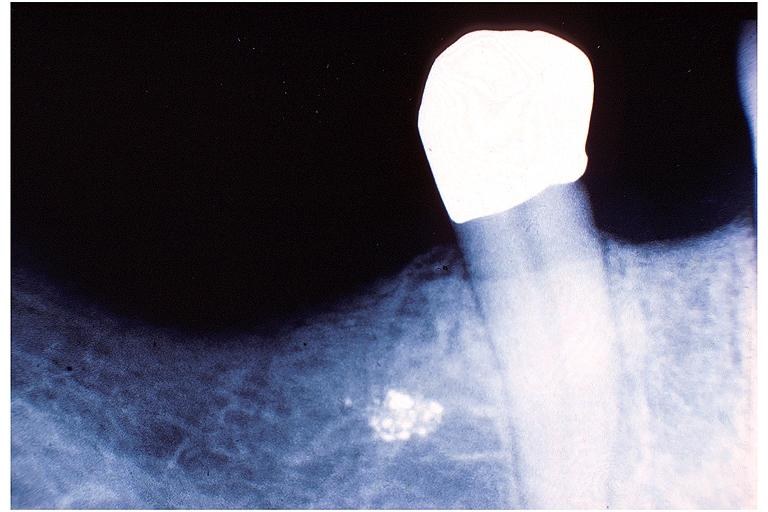what does this image show?
Answer the question using a single word or phrase. Amalgam tattoo 